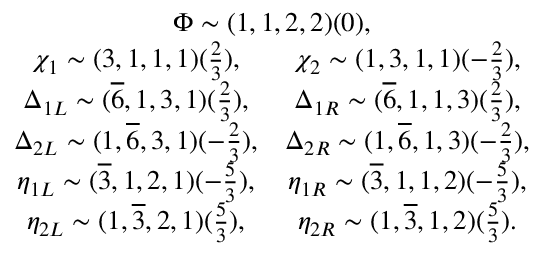<formula> <loc_0><loc_0><loc_500><loc_500>\begin{array} { c } { \Phi \sim ( 1 , 1 , 2 , 2 ) ( 0 ) , } \\ { { \begin{array} { c c } { { \chi _ { 1 } \sim ( 3 , 1 , 1 , 1 ) ( \frac { 2 } { 3 } ) , } } & { { \chi _ { 2 } \sim ( 1 , 3 , 1 , 1 ) ( - \frac { 2 } { 3 } ) , } } \\ { { \Delta _ { 1 L } \sim ( \overline { 6 } , 1 , 3 , 1 ) ( \frac { 2 } { 3 } ) , } } & { { \Delta _ { 1 R } \sim ( \overline { 6 } , 1 , 1 , 3 ) ( \frac { 2 } { 3 } ) , } } \\ { { \Delta _ { 2 L } \sim ( 1 , \overline { 6 } , 3 , 1 ) ( - \frac { 2 } { 3 } ) , } } & { { \Delta _ { 2 R } \sim ( 1 , \overline { 6 } , 1 , 3 ) ( - \frac { 2 } { 3 } ) , } } \\ { { \eta _ { 1 L } \sim ( \overline { 3 } , 1 , 2 , 1 ) ( - \frac { 5 } { 3 } ) , } } & { { \eta _ { 1 R } \sim ( \overline { 3 } , 1 , 1 , 2 ) ( - \frac { 5 } { 3 } ) , } } \\ { { \eta _ { 2 L } \sim ( 1 , \overline { 3 } , 2 , 1 ) ( \frac { 5 } { 3 } ) , } } & { { \eta _ { 2 R } \sim ( 1 , \overline { 3 } , 1 , 2 ) ( \frac { 5 } { 3 } ) . } } \end{array} } } \end{array}</formula> 